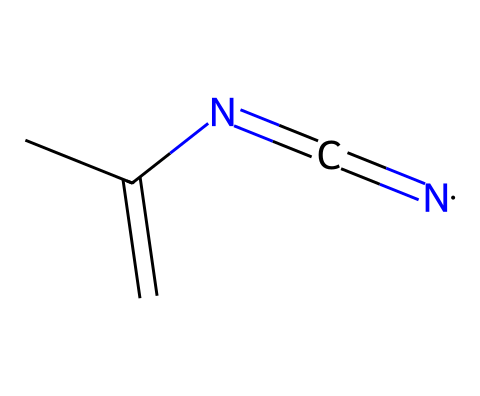What is the total number of carbon atoms in this molecule? The provided SMILES representation shows a structure that includes "CC", indicating two carbon atoms in the chain. Therefore, the total number of carbon atoms here is two.
Answer: two How many nitrogen atoms are present in the chemical structure? In the SMILES notation, we can identify "N" appears twice, indicating that there are two nitrogen atoms in the molecule.
Answer: two What type of chemical is represented here? The presence of a carbon atom with a valence of two indicates that this molecule contains a reactive carbene. This is a characteristic structure of carbenes.
Answer: carbene Which functional group is represented in this molecule? The presence of the "=C" bond near the nitrogen indicates that this molecule features an imine functional group, where a carbon is double-bonded to a nitrogen.
Answer: imine Does this molecule indicate potential stability when used in heat-resistant coatings? The presence of carbenes, known for their unique reactivity and stability in certain contexts, suggests that this molecule could withstand high temperatures, making it suitable for heat-resistant coatings.
Answer: yes What kind of bonding does the central carbon exhibit with the adjacent atoms? The central carbon in the structure shows a double bond with the nitrogen atoms and a single bond with the other carbon, which indicates that it has a mix of bonding types: single and double.
Answer: mixed bonding Is this molecule likely to be reactive or inert? Due to the presence of a carbene, which is generally highly reactive due to its electron-deficient nature, we can conclude that this molecule is likely reactive.
Answer: reactive 